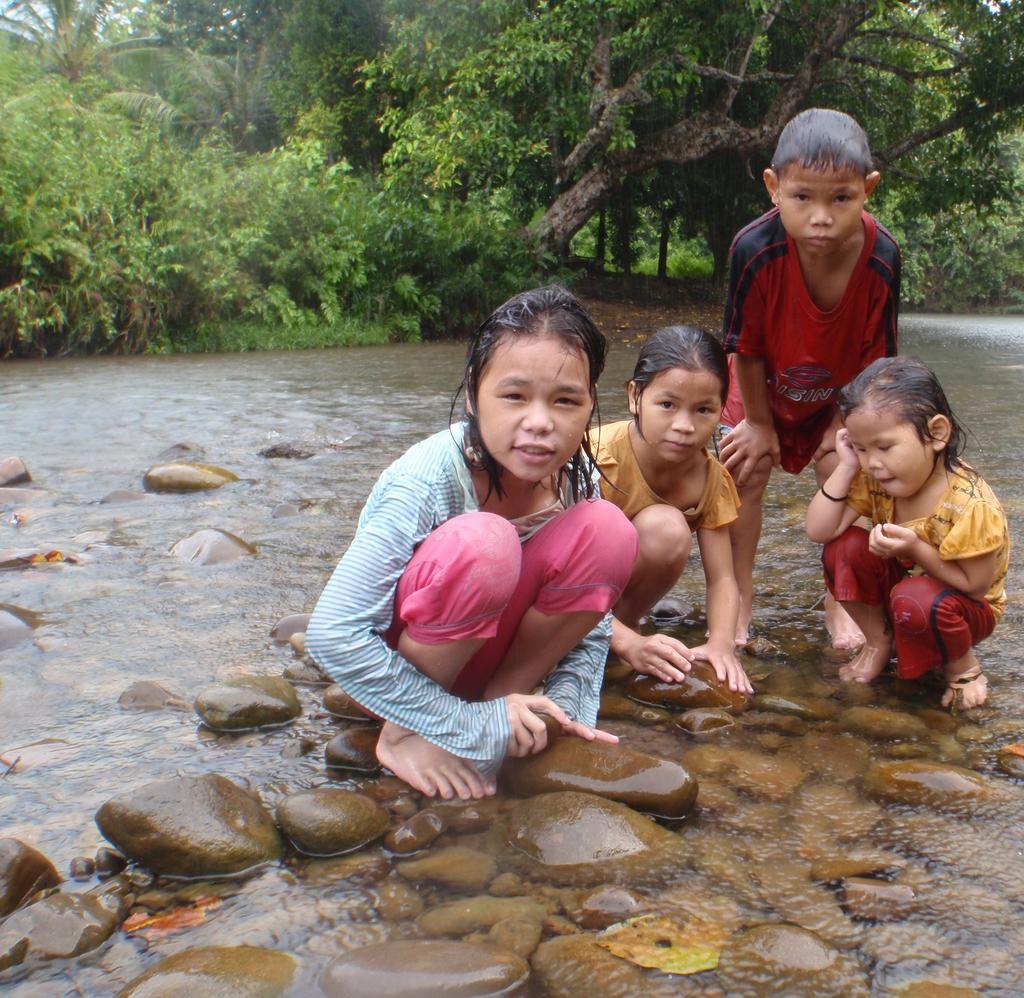Describe this image in one or two sentences. In this picture there are few kids crouching on stones which are in water and there are few trees in the background. 